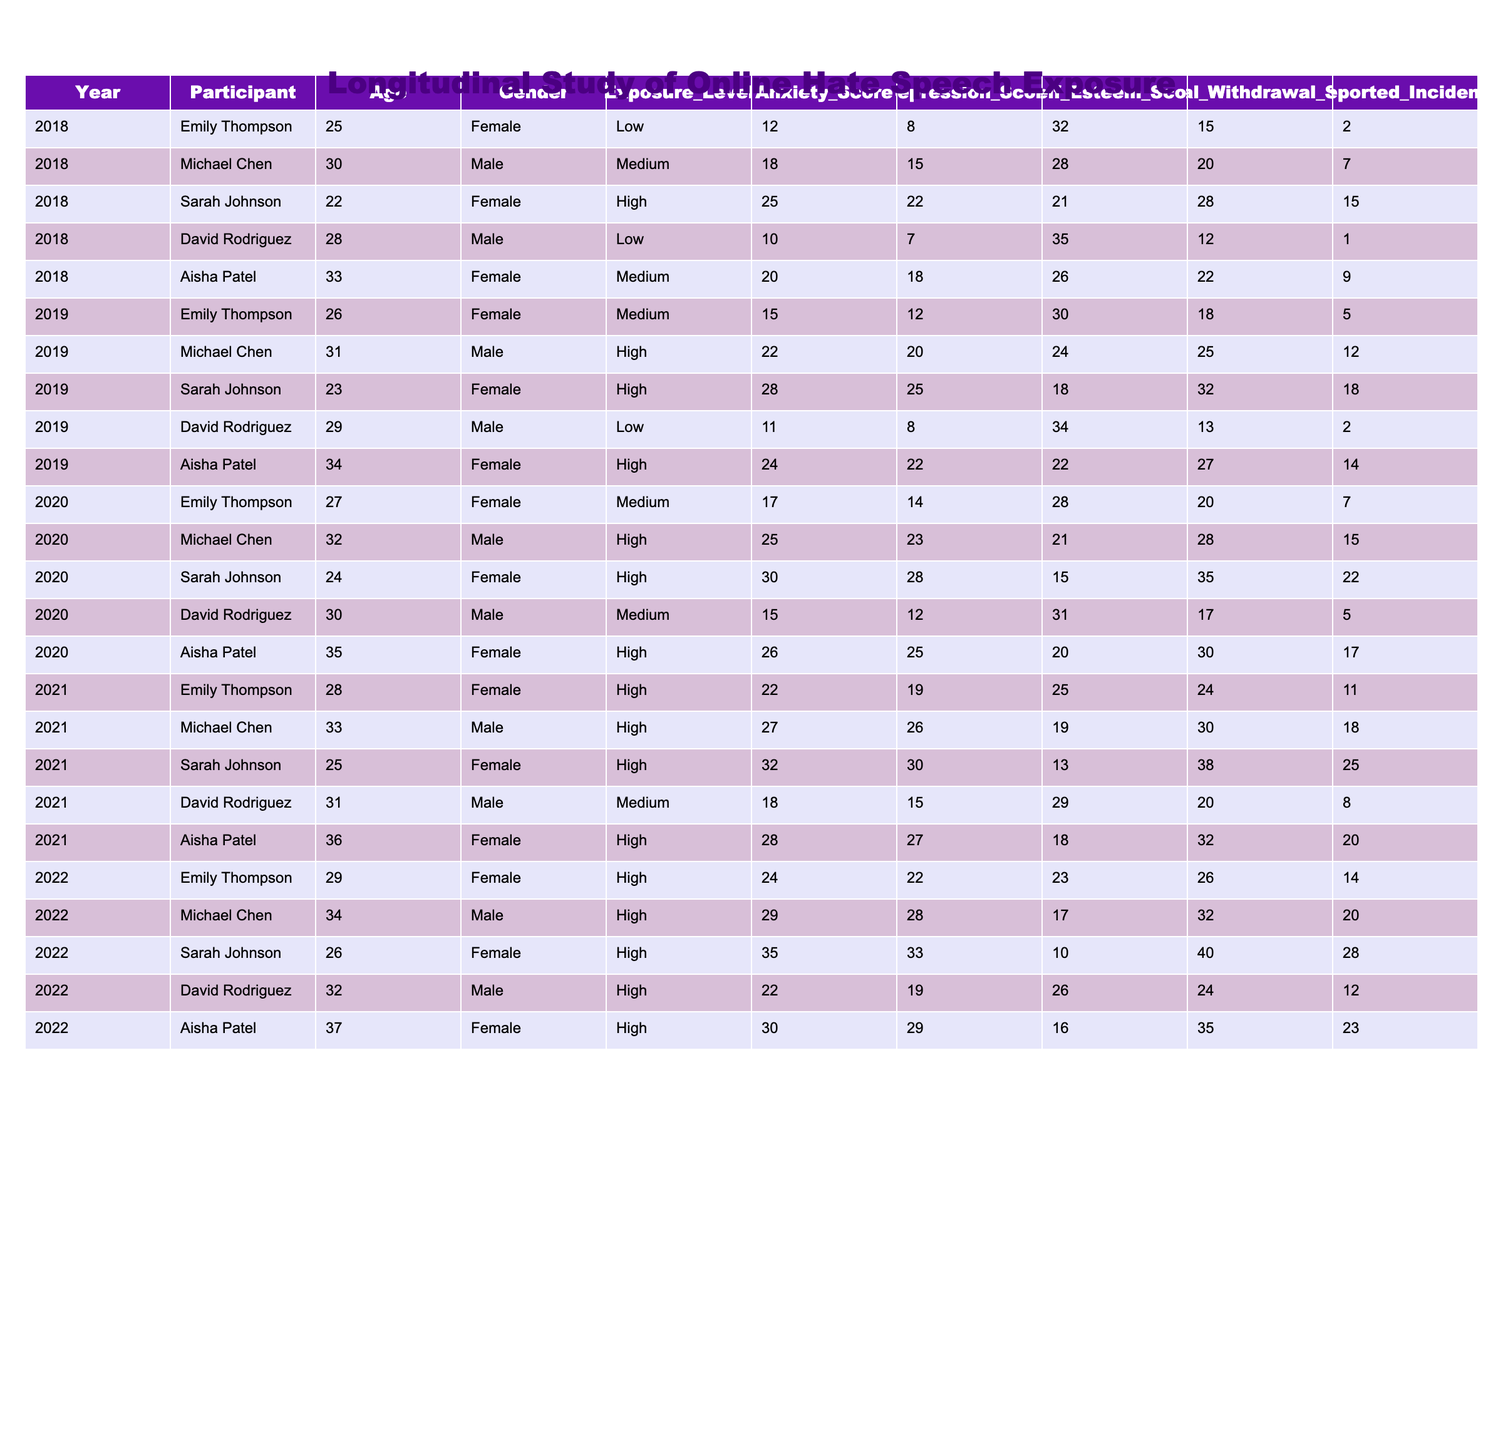What was Sarah Johnson's anxiety score in 2022? Looking at the row for Sarah Johnson in 2022, her anxiety score is recorded as 35.
Answer: 35 What was the reported incident count for Michael Chen in 2019? From the table, Michael Chen's reported incidents in 2019 are listed as 12.
Answer: 12 Who had the highest depression score in 2021? Checking the depression scores for all participants in 2021, Sarah Johnson had the highest score of 30.
Answer: Sarah Johnson What is the average self-esteem score for Emily Thompson across all years? Emily Thompson's self-esteem scores are 32, 30, 28, 25, and 23 over the five years. Summing these gives 168, and dividing by 5 results in an average of 33.6.
Answer: 33.6 Did Aisha Patel's exposure level ever decrease over the five years? Aisha Patel's exposure levels in the dataset were Medium in 2018, High in 2019, 2020, 2021, and 2022. Since the levels did not decrease, the answer is no.
Answer: No What is the difference between the highest and lowest anxiety scores recorded in 2022? In 2022, the highest anxiety score is 35 (Sarah Johnson) and the lowest is 22 (David Rodriguez). The difference is 35 - 22 = 13.
Answer: 13 Which year did David Rodriguez report the highest number of incidents? Checking David Rodriguez's incident reports, the highest count is 8 in 2021, compared to 2 in 2018, 2 in 2019, 5 in 2020, and 12 in 2022.
Answer: 8 in 2021 What is the average age of participants in 2020? The ages of participants in 2020 are 27 (Emily Thompson), 32 (Michael Chen), 24 (Sarah Johnson), 30 (David Rodriguez), and 35 (Aisha Patel), totaling 148. Dividing by 5 results in an average of 29.6.
Answer: 29.6 Has any participant maintained a consistent self-esteem score over the five years? Analyzing the self-esteem scores for each participant, none maintained the same score across all five years; all displayed variations.
Answer: No Who experienced the most significant change in anxiety score from 2018 to 2022? Calculating the change in anxiety scores: Emily Thompson (12 to 24, change of 12), Michael Chen (18 to 29, change of 11), Sarah Johnson (25 to 35, change of 10), David Rodriguez (10 to 22, change of 12), and Aisha Patel (20 to 30, change of 10). The largest change is 12, observed for both Emily Thompson and David Rodriguez.
Answer: Emily Thompson and David Rodriguez (both 12) 